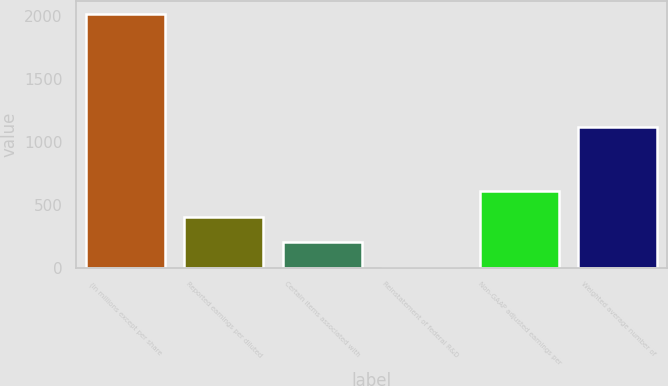<chart> <loc_0><loc_0><loc_500><loc_500><bar_chart><fcel>(In millions except per share<fcel>Reported earnings per diluted<fcel>Certain items associated with<fcel>Reinstatement of federal R&D<fcel>Non-GAAP adjusted earnings per<fcel>Weighted average number of<nl><fcel>2016<fcel>403.24<fcel>201.64<fcel>0.04<fcel>604.84<fcel>1116<nl></chart> 